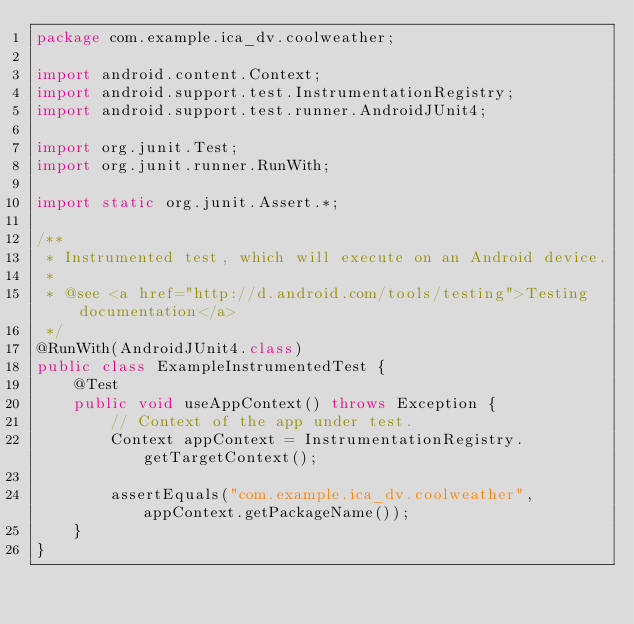<code> <loc_0><loc_0><loc_500><loc_500><_Java_>package com.example.ica_dv.coolweather;

import android.content.Context;
import android.support.test.InstrumentationRegistry;
import android.support.test.runner.AndroidJUnit4;

import org.junit.Test;
import org.junit.runner.RunWith;

import static org.junit.Assert.*;

/**
 * Instrumented test, which will execute on an Android device.
 *
 * @see <a href="http://d.android.com/tools/testing">Testing documentation</a>
 */
@RunWith(AndroidJUnit4.class)
public class ExampleInstrumentedTest {
    @Test
    public void useAppContext() throws Exception {
        // Context of the app under test.
        Context appContext = InstrumentationRegistry.getTargetContext();

        assertEquals("com.example.ica_dv.coolweather", appContext.getPackageName());
    }
}
</code> 